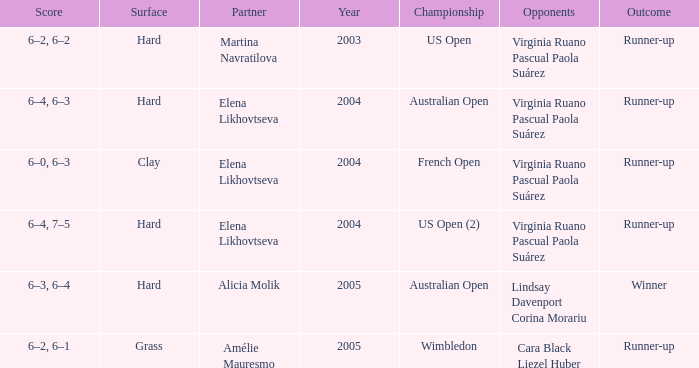When alicia molik is the partner what is the outcome? Winner. 